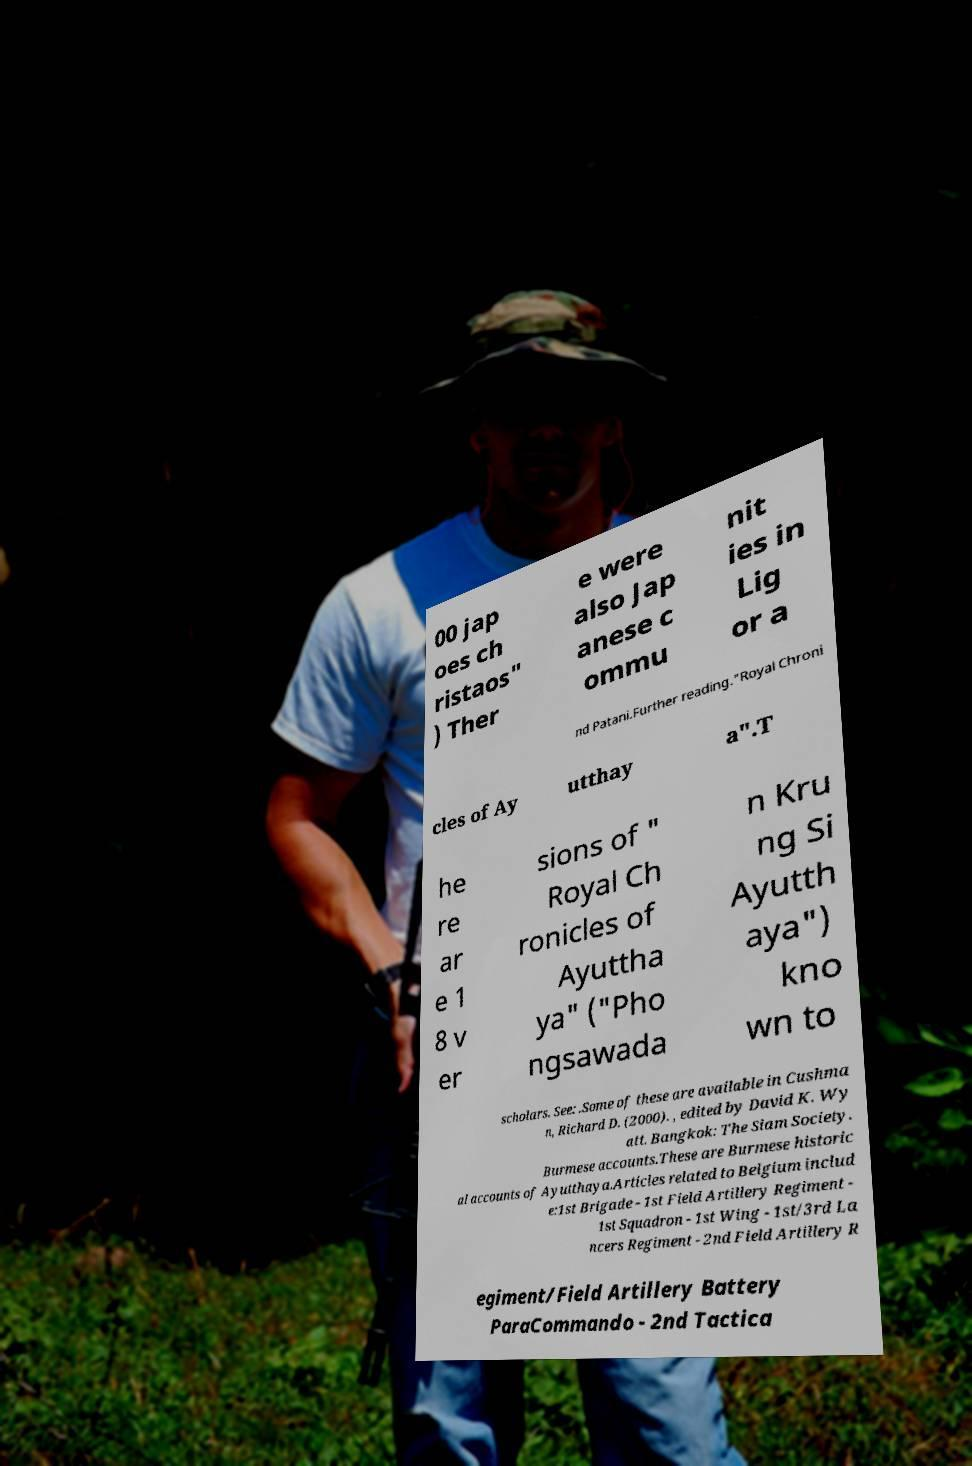Please identify and transcribe the text found in this image. 00 jap oes ch ristaos" ) Ther e were also Jap anese c ommu nit ies in Lig or a nd Patani.Further reading."Royal Chroni cles of Ay utthay a".T he re ar e 1 8 v er sions of " Royal Ch ronicles of Ayuttha ya" ("Pho ngsawada n Kru ng Si Ayutth aya") kno wn to scholars. See: .Some of these are available in Cushma n, Richard D. (2000). , edited by David K. Wy att. Bangkok: The Siam Society. Burmese accounts.These are Burmese historic al accounts of Ayutthaya.Articles related to Belgium includ e:1st Brigade - 1st Field Artillery Regiment - 1st Squadron - 1st Wing - 1st/3rd La ncers Regiment - 2nd Field Artillery R egiment/Field Artillery Battery ParaCommando - 2nd Tactica 